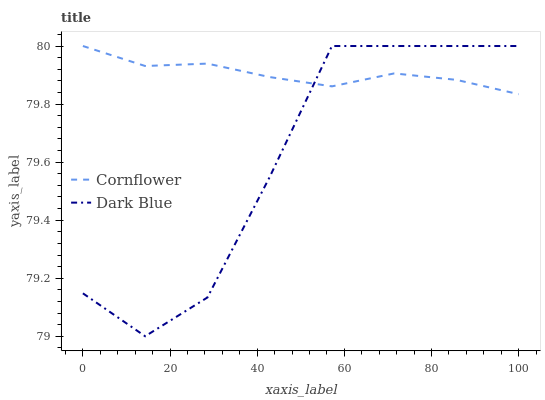Does Dark Blue have the minimum area under the curve?
Answer yes or no. Yes. Does Cornflower have the maximum area under the curve?
Answer yes or no. Yes. Does Dark Blue have the maximum area under the curve?
Answer yes or no. No. Is Cornflower the smoothest?
Answer yes or no. Yes. Is Dark Blue the roughest?
Answer yes or no. Yes. Is Dark Blue the smoothest?
Answer yes or no. No. Does Dark Blue have the lowest value?
Answer yes or no. Yes. Does Dark Blue have the highest value?
Answer yes or no. Yes. Does Dark Blue intersect Cornflower?
Answer yes or no. Yes. Is Dark Blue less than Cornflower?
Answer yes or no. No. Is Dark Blue greater than Cornflower?
Answer yes or no. No. 